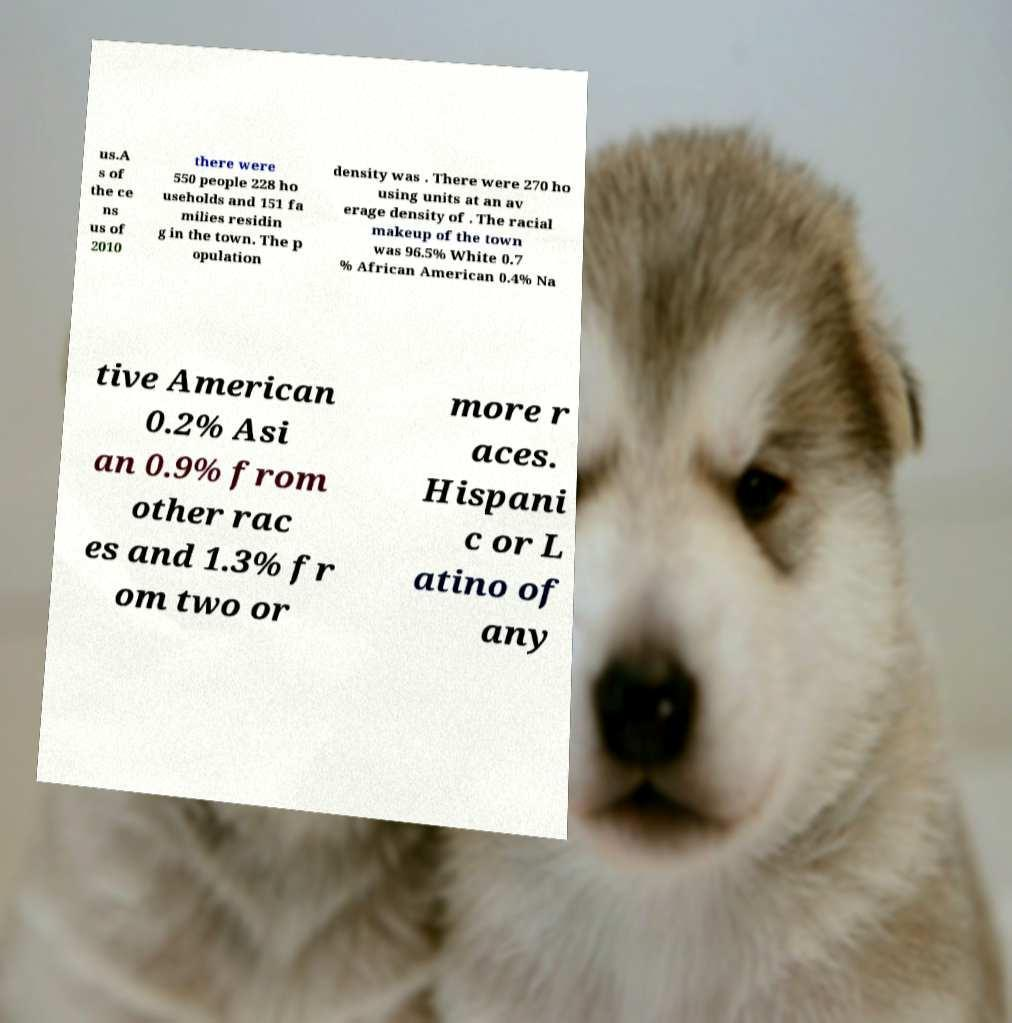Please read and relay the text visible in this image. What does it say? us.A s of the ce ns us of 2010 there were 550 people 228 ho useholds and 151 fa milies residin g in the town. The p opulation density was . There were 270 ho using units at an av erage density of . The racial makeup of the town was 96.5% White 0.7 % African American 0.4% Na tive American 0.2% Asi an 0.9% from other rac es and 1.3% fr om two or more r aces. Hispani c or L atino of any 